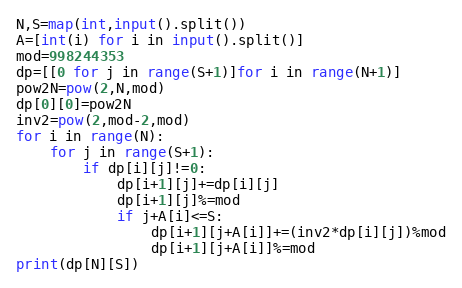<code> <loc_0><loc_0><loc_500><loc_500><_Python_>N,S=map(int,input().split())
A=[int(i) for i in input().split()]
mod=998244353
dp=[[0 for j in range(S+1)]for i in range(N+1)]
pow2N=pow(2,N,mod)
dp[0][0]=pow2N
inv2=pow(2,mod-2,mod)
for i in range(N):
    for j in range(S+1):
        if dp[i][j]!=0:
            dp[i+1][j]+=dp[i][j]
            dp[i+1][j]%=mod
            if j+A[i]<=S:
                dp[i+1][j+A[i]]+=(inv2*dp[i][j])%mod
                dp[i+1][j+A[i]]%=mod
print(dp[N][S])
</code> 